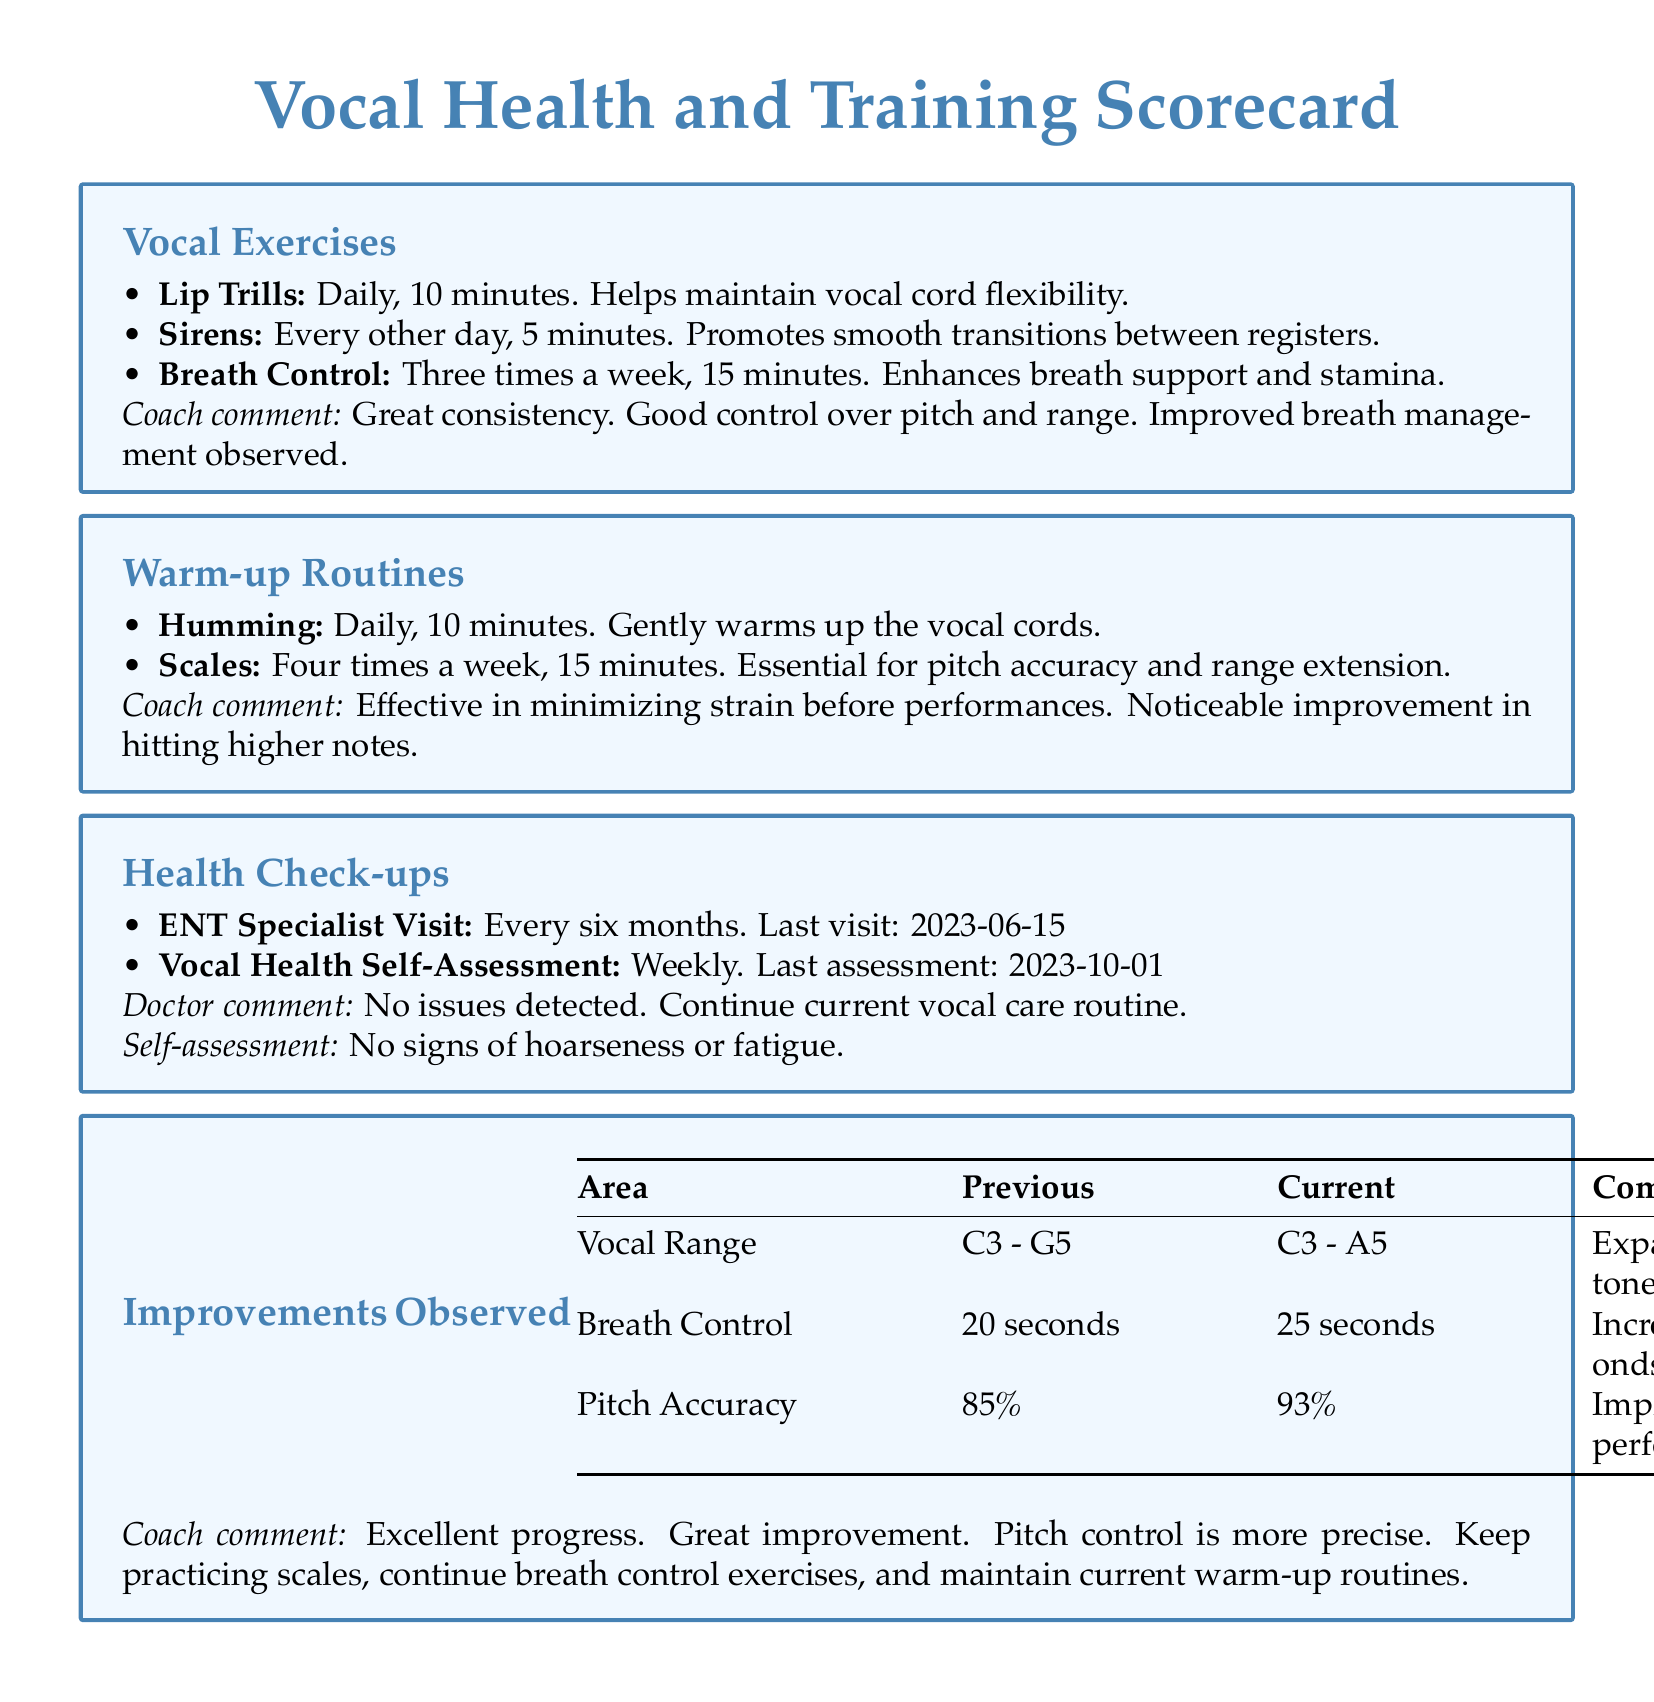What is the duration of daily lip trills? The document states that lip trills are to be performed daily for 10 minutes.
Answer: 10 minutes How often is the ENT specialist visited? The document mentions that the ENT specialist visit occurs every six months.
Answer: Every six months What improvement was observed in vocal range? The scorecard specifies that the upper range expanded by a full tone from C3 - G5 to C3 - A5.
Answer: Expanded by a full tone How many seconds increased in breath control? The improvement in breath control is listed as an increase from 20 seconds to 25 seconds, which is 5 seconds.
Answer: 5 seconds What is the current pitch accuracy percentage? The document indicates that the current pitch accuracy is 93%.
Answer: 93% What type of exercises are done three times a week? Breath control is the exercise that is performed three times a week, as noted in the document.
Answer: Breath control What does the doctor suggest continuing? The doctor advises continuing the current vocal care routine.
Answer: Current vocal care routine What was the last self-assessment date? The document lists the last vocal health self-assessment date as 2023-10-01.
Answer: 2023-10-01 